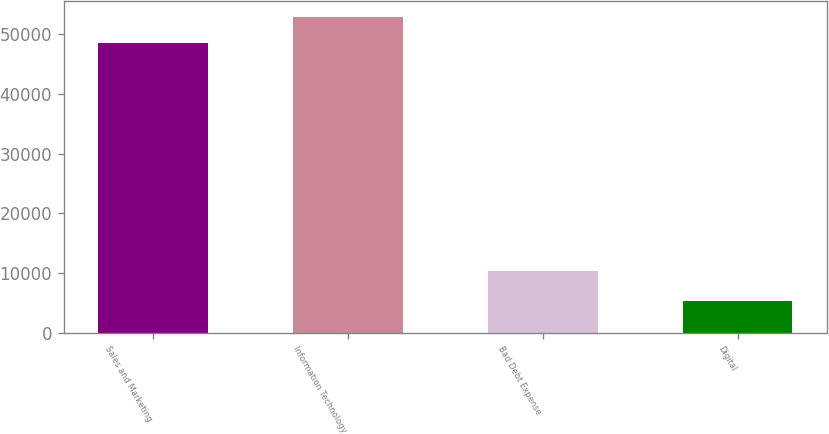<chart> <loc_0><loc_0><loc_500><loc_500><bar_chart><fcel>Sales and Marketing<fcel>Information Technology<fcel>Bad Debt Expense<fcel>Digital<nl><fcel>48580<fcel>52907.2<fcel>10334<fcel>5391<nl></chart> 